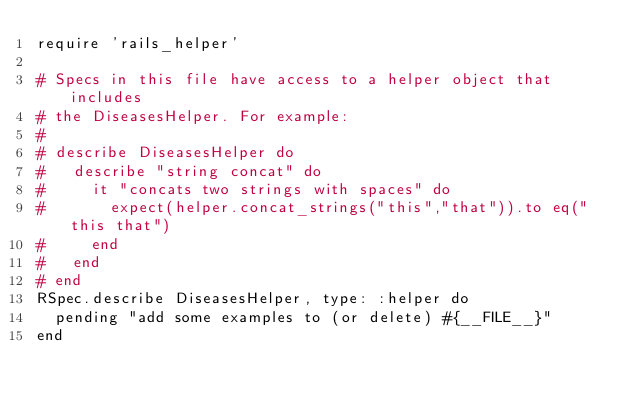Convert code to text. <code><loc_0><loc_0><loc_500><loc_500><_Ruby_>require 'rails_helper'

# Specs in this file have access to a helper object that includes
# the DiseasesHelper. For example:
#
# describe DiseasesHelper do
#   describe "string concat" do
#     it "concats two strings with spaces" do
#       expect(helper.concat_strings("this","that")).to eq("this that")
#     end
#   end
# end
RSpec.describe DiseasesHelper, type: :helper do
  pending "add some examples to (or delete) #{__FILE__}"
end
</code> 